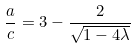<formula> <loc_0><loc_0><loc_500><loc_500>\frac { a } { c } = 3 - \frac { 2 } { \sqrt { 1 - 4 \lambda } }</formula> 